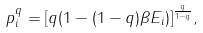Convert formula to latex. <formula><loc_0><loc_0><loc_500><loc_500>p _ { i } ^ { q } = [ q ( 1 - ( 1 - q ) \beta E _ { i } ) ] ^ { \frac { q } { 1 - q } } ,</formula> 